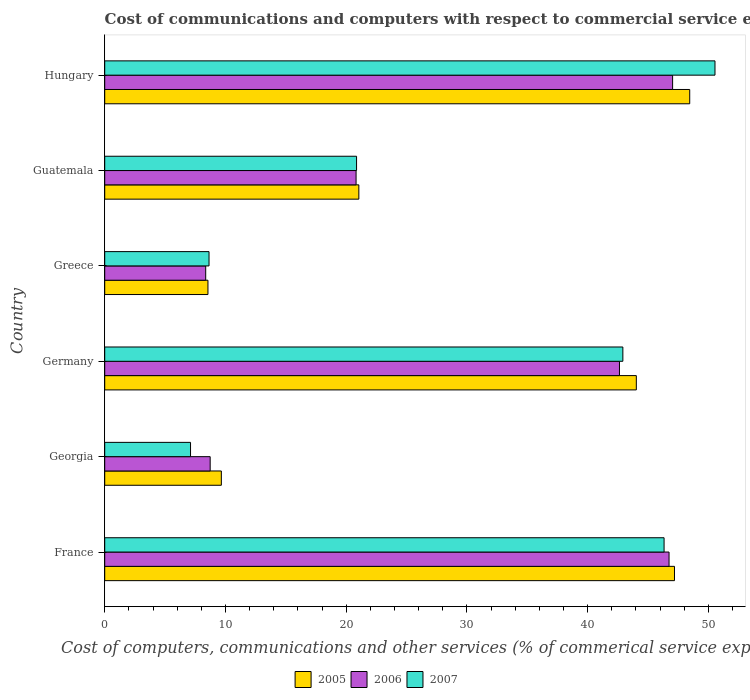How many different coloured bars are there?
Your response must be concise. 3. How many groups of bars are there?
Make the answer very short. 6. What is the label of the 1st group of bars from the top?
Give a very brief answer. Hungary. In how many cases, is the number of bars for a given country not equal to the number of legend labels?
Your response must be concise. 0. What is the cost of communications and computers in 2005 in Georgia?
Offer a very short reply. 9.66. Across all countries, what is the maximum cost of communications and computers in 2006?
Offer a very short reply. 47.04. Across all countries, what is the minimum cost of communications and computers in 2006?
Your answer should be compact. 8.36. In which country was the cost of communications and computers in 2006 maximum?
Offer a very short reply. Hungary. In which country was the cost of communications and computers in 2005 minimum?
Offer a terse response. Greece. What is the total cost of communications and computers in 2006 in the graph?
Make the answer very short. 174.34. What is the difference between the cost of communications and computers in 2007 in Georgia and that in Hungary?
Provide a short and direct response. -43.44. What is the difference between the cost of communications and computers in 2007 in Germany and the cost of communications and computers in 2005 in France?
Make the answer very short. -4.28. What is the average cost of communications and computers in 2007 per country?
Make the answer very short. 29.4. What is the difference between the cost of communications and computers in 2005 and cost of communications and computers in 2006 in Hungary?
Make the answer very short. 1.42. What is the ratio of the cost of communications and computers in 2005 in Germany to that in Hungary?
Your answer should be compact. 0.91. Is the cost of communications and computers in 2005 in Georgia less than that in Guatemala?
Offer a very short reply. Yes. What is the difference between the highest and the second highest cost of communications and computers in 2005?
Offer a terse response. 1.26. What is the difference between the highest and the lowest cost of communications and computers in 2006?
Ensure brevity in your answer.  38.67. What does the 2nd bar from the top in Guatemala represents?
Make the answer very short. 2006. Are all the bars in the graph horizontal?
Provide a succinct answer. Yes. Does the graph contain any zero values?
Your answer should be very brief. No. Does the graph contain grids?
Make the answer very short. No. How many legend labels are there?
Your response must be concise. 3. What is the title of the graph?
Ensure brevity in your answer.  Cost of communications and computers with respect to commercial service exports. What is the label or title of the X-axis?
Ensure brevity in your answer.  Cost of computers, communications and other services (% of commerical service exports). What is the Cost of computers, communications and other services (% of commerical service exports) of 2005 in France?
Ensure brevity in your answer.  47.19. What is the Cost of computers, communications and other services (% of commerical service exports) of 2006 in France?
Your answer should be compact. 46.74. What is the Cost of computers, communications and other services (% of commerical service exports) of 2007 in France?
Provide a short and direct response. 46.33. What is the Cost of computers, communications and other services (% of commerical service exports) of 2005 in Georgia?
Keep it short and to the point. 9.66. What is the Cost of computers, communications and other services (% of commerical service exports) of 2006 in Georgia?
Provide a short and direct response. 8.74. What is the Cost of computers, communications and other services (% of commerical service exports) of 2007 in Georgia?
Provide a succinct answer. 7.11. What is the Cost of computers, communications and other services (% of commerical service exports) of 2005 in Germany?
Keep it short and to the point. 44.03. What is the Cost of computers, communications and other services (% of commerical service exports) of 2006 in Germany?
Make the answer very short. 42.64. What is the Cost of computers, communications and other services (% of commerical service exports) in 2007 in Germany?
Provide a succinct answer. 42.92. What is the Cost of computers, communications and other services (% of commerical service exports) in 2005 in Greece?
Keep it short and to the point. 8.55. What is the Cost of computers, communications and other services (% of commerical service exports) in 2006 in Greece?
Provide a succinct answer. 8.36. What is the Cost of computers, communications and other services (% of commerical service exports) in 2007 in Greece?
Provide a short and direct response. 8.64. What is the Cost of computers, communications and other services (% of commerical service exports) of 2005 in Guatemala?
Your answer should be compact. 21.05. What is the Cost of computers, communications and other services (% of commerical service exports) in 2006 in Guatemala?
Your answer should be very brief. 20.82. What is the Cost of computers, communications and other services (% of commerical service exports) of 2007 in Guatemala?
Offer a very short reply. 20.86. What is the Cost of computers, communications and other services (% of commerical service exports) of 2005 in Hungary?
Offer a terse response. 48.46. What is the Cost of computers, communications and other services (% of commerical service exports) of 2006 in Hungary?
Provide a succinct answer. 47.04. What is the Cost of computers, communications and other services (% of commerical service exports) in 2007 in Hungary?
Offer a terse response. 50.55. Across all countries, what is the maximum Cost of computers, communications and other services (% of commerical service exports) in 2005?
Provide a succinct answer. 48.46. Across all countries, what is the maximum Cost of computers, communications and other services (% of commerical service exports) of 2006?
Your answer should be compact. 47.04. Across all countries, what is the maximum Cost of computers, communications and other services (% of commerical service exports) in 2007?
Offer a very short reply. 50.55. Across all countries, what is the minimum Cost of computers, communications and other services (% of commerical service exports) in 2005?
Offer a terse response. 8.55. Across all countries, what is the minimum Cost of computers, communications and other services (% of commerical service exports) in 2006?
Provide a succinct answer. 8.36. Across all countries, what is the minimum Cost of computers, communications and other services (% of commerical service exports) in 2007?
Offer a terse response. 7.11. What is the total Cost of computers, communications and other services (% of commerical service exports) of 2005 in the graph?
Give a very brief answer. 178.94. What is the total Cost of computers, communications and other services (% of commerical service exports) in 2006 in the graph?
Give a very brief answer. 174.34. What is the total Cost of computers, communications and other services (% of commerical service exports) in 2007 in the graph?
Make the answer very short. 176.41. What is the difference between the Cost of computers, communications and other services (% of commerical service exports) in 2005 in France and that in Georgia?
Ensure brevity in your answer.  37.53. What is the difference between the Cost of computers, communications and other services (% of commerical service exports) of 2006 in France and that in Georgia?
Your response must be concise. 38.01. What is the difference between the Cost of computers, communications and other services (% of commerical service exports) of 2007 in France and that in Georgia?
Your response must be concise. 39.22. What is the difference between the Cost of computers, communications and other services (% of commerical service exports) of 2005 in France and that in Germany?
Ensure brevity in your answer.  3.16. What is the difference between the Cost of computers, communications and other services (% of commerical service exports) of 2006 in France and that in Germany?
Offer a terse response. 4.11. What is the difference between the Cost of computers, communications and other services (% of commerical service exports) in 2007 in France and that in Germany?
Make the answer very short. 3.41. What is the difference between the Cost of computers, communications and other services (% of commerical service exports) of 2005 in France and that in Greece?
Offer a terse response. 38.64. What is the difference between the Cost of computers, communications and other services (% of commerical service exports) of 2006 in France and that in Greece?
Your answer should be compact. 38.38. What is the difference between the Cost of computers, communications and other services (% of commerical service exports) of 2007 in France and that in Greece?
Offer a terse response. 37.69. What is the difference between the Cost of computers, communications and other services (% of commerical service exports) of 2005 in France and that in Guatemala?
Ensure brevity in your answer.  26.14. What is the difference between the Cost of computers, communications and other services (% of commerical service exports) in 2006 in France and that in Guatemala?
Your response must be concise. 25.92. What is the difference between the Cost of computers, communications and other services (% of commerical service exports) of 2007 in France and that in Guatemala?
Provide a succinct answer. 25.47. What is the difference between the Cost of computers, communications and other services (% of commerical service exports) in 2005 in France and that in Hungary?
Keep it short and to the point. -1.26. What is the difference between the Cost of computers, communications and other services (% of commerical service exports) of 2006 in France and that in Hungary?
Make the answer very short. -0.3. What is the difference between the Cost of computers, communications and other services (% of commerical service exports) in 2007 in France and that in Hungary?
Provide a succinct answer. -4.22. What is the difference between the Cost of computers, communications and other services (% of commerical service exports) in 2005 in Georgia and that in Germany?
Provide a succinct answer. -34.37. What is the difference between the Cost of computers, communications and other services (% of commerical service exports) of 2006 in Georgia and that in Germany?
Offer a very short reply. -33.9. What is the difference between the Cost of computers, communications and other services (% of commerical service exports) of 2007 in Georgia and that in Germany?
Provide a short and direct response. -35.81. What is the difference between the Cost of computers, communications and other services (% of commerical service exports) of 2005 in Georgia and that in Greece?
Provide a short and direct response. 1.11. What is the difference between the Cost of computers, communications and other services (% of commerical service exports) of 2006 in Georgia and that in Greece?
Your answer should be very brief. 0.37. What is the difference between the Cost of computers, communications and other services (% of commerical service exports) in 2007 in Georgia and that in Greece?
Offer a terse response. -1.53. What is the difference between the Cost of computers, communications and other services (% of commerical service exports) of 2005 in Georgia and that in Guatemala?
Your answer should be very brief. -11.39. What is the difference between the Cost of computers, communications and other services (% of commerical service exports) of 2006 in Georgia and that in Guatemala?
Ensure brevity in your answer.  -12.08. What is the difference between the Cost of computers, communications and other services (% of commerical service exports) of 2007 in Georgia and that in Guatemala?
Make the answer very short. -13.75. What is the difference between the Cost of computers, communications and other services (% of commerical service exports) in 2005 in Georgia and that in Hungary?
Make the answer very short. -38.8. What is the difference between the Cost of computers, communications and other services (% of commerical service exports) in 2006 in Georgia and that in Hungary?
Make the answer very short. -38.3. What is the difference between the Cost of computers, communications and other services (% of commerical service exports) of 2007 in Georgia and that in Hungary?
Offer a terse response. -43.44. What is the difference between the Cost of computers, communications and other services (% of commerical service exports) of 2005 in Germany and that in Greece?
Make the answer very short. 35.48. What is the difference between the Cost of computers, communications and other services (% of commerical service exports) of 2006 in Germany and that in Greece?
Provide a succinct answer. 34.27. What is the difference between the Cost of computers, communications and other services (% of commerical service exports) in 2007 in Germany and that in Greece?
Offer a very short reply. 34.28. What is the difference between the Cost of computers, communications and other services (% of commerical service exports) in 2005 in Germany and that in Guatemala?
Provide a short and direct response. 22.98. What is the difference between the Cost of computers, communications and other services (% of commerical service exports) in 2006 in Germany and that in Guatemala?
Make the answer very short. 21.82. What is the difference between the Cost of computers, communications and other services (% of commerical service exports) in 2007 in Germany and that in Guatemala?
Offer a terse response. 22.06. What is the difference between the Cost of computers, communications and other services (% of commerical service exports) in 2005 in Germany and that in Hungary?
Give a very brief answer. -4.42. What is the difference between the Cost of computers, communications and other services (% of commerical service exports) in 2006 in Germany and that in Hungary?
Make the answer very short. -4.4. What is the difference between the Cost of computers, communications and other services (% of commerical service exports) of 2007 in Germany and that in Hungary?
Keep it short and to the point. -7.63. What is the difference between the Cost of computers, communications and other services (% of commerical service exports) of 2005 in Greece and that in Guatemala?
Offer a terse response. -12.5. What is the difference between the Cost of computers, communications and other services (% of commerical service exports) in 2006 in Greece and that in Guatemala?
Your response must be concise. -12.45. What is the difference between the Cost of computers, communications and other services (% of commerical service exports) of 2007 in Greece and that in Guatemala?
Keep it short and to the point. -12.22. What is the difference between the Cost of computers, communications and other services (% of commerical service exports) of 2005 in Greece and that in Hungary?
Your response must be concise. -39.91. What is the difference between the Cost of computers, communications and other services (% of commerical service exports) in 2006 in Greece and that in Hungary?
Your answer should be compact. -38.67. What is the difference between the Cost of computers, communications and other services (% of commerical service exports) in 2007 in Greece and that in Hungary?
Make the answer very short. -41.91. What is the difference between the Cost of computers, communications and other services (% of commerical service exports) in 2005 in Guatemala and that in Hungary?
Your response must be concise. -27.41. What is the difference between the Cost of computers, communications and other services (% of commerical service exports) in 2006 in Guatemala and that in Hungary?
Your response must be concise. -26.22. What is the difference between the Cost of computers, communications and other services (% of commerical service exports) in 2007 in Guatemala and that in Hungary?
Your response must be concise. -29.69. What is the difference between the Cost of computers, communications and other services (% of commerical service exports) of 2005 in France and the Cost of computers, communications and other services (% of commerical service exports) of 2006 in Georgia?
Offer a very short reply. 38.46. What is the difference between the Cost of computers, communications and other services (% of commerical service exports) of 2005 in France and the Cost of computers, communications and other services (% of commerical service exports) of 2007 in Georgia?
Provide a succinct answer. 40.09. What is the difference between the Cost of computers, communications and other services (% of commerical service exports) of 2006 in France and the Cost of computers, communications and other services (% of commerical service exports) of 2007 in Georgia?
Your response must be concise. 39.64. What is the difference between the Cost of computers, communications and other services (% of commerical service exports) in 2005 in France and the Cost of computers, communications and other services (% of commerical service exports) in 2006 in Germany?
Your response must be concise. 4.56. What is the difference between the Cost of computers, communications and other services (% of commerical service exports) of 2005 in France and the Cost of computers, communications and other services (% of commerical service exports) of 2007 in Germany?
Your answer should be very brief. 4.28. What is the difference between the Cost of computers, communications and other services (% of commerical service exports) in 2006 in France and the Cost of computers, communications and other services (% of commerical service exports) in 2007 in Germany?
Keep it short and to the point. 3.83. What is the difference between the Cost of computers, communications and other services (% of commerical service exports) of 2005 in France and the Cost of computers, communications and other services (% of commerical service exports) of 2006 in Greece?
Your answer should be compact. 38.83. What is the difference between the Cost of computers, communications and other services (% of commerical service exports) of 2005 in France and the Cost of computers, communications and other services (% of commerical service exports) of 2007 in Greece?
Keep it short and to the point. 38.55. What is the difference between the Cost of computers, communications and other services (% of commerical service exports) in 2006 in France and the Cost of computers, communications and other services (% of commerical service exports) in 2007 in Greece?
Your answer should be compact. 38.1. What is the difference between the Cost of computers, communications and other services (% of commerical service exports) in 2005 in France and the Cost of computers, communications and other services (% of commerical service exports) in 2006 in Guatemala?
Offer a terse response. 26.37. What is the difference between the Cost of computers, communications and other services (% of commerical service exports) in 2005 in France and the Cost of computers, communications and other services (% of commerical service exports) in 2007 in Guatemala?
Provide a short and direct response. 26.33. What is the difference between the Cost of computers, communications and other services (% of commerical service exports) in 2006 in France and the Cost of computers, communications and other services (% of commerical service exports) in 2007 in Guatemala?
Give a very brief answer. 25.88. What is the difference between the Cost of computers, communications and other services (% of commerical service exports) of 2005 in France and the Cost of computers, communications and other services (% of commerical service exports) of 2006 in Hungary?
Provide a short and direct response. 0.16. What is the difference between the Cost of computers, communications and other services (% of commerical service exports) of 2005 in France and the Cost of computers, communications and other services (% of commerical service exports) of 2007 in Hungary?
Provide a short and direct response. -3.35. What is the difference between the Cost of computers, communications and other services (% of commerical service exports) of 2006 in France and the Cost of computers, communications and other services (% of commerical service exports) of 2007 in Hungary?
Ensure brevity in your answer.  -3.8. What is the difference between the Cost of computers, communications and other services (% of commerical service exports) in 2005 in Georgia and the Cost of computers, communications and other services (% of commerical service exports) in 2006 in Germany?
Offer a terse response. -32.98. What is the difference between the Cost of computers, communications and other services (% of commerical service exports) in 2005 in Georgia and the Cost of computers, communications and other services (% of commerical service exports) in 2007 in Germany?
Provide a succinct answer. -33.26. What is the difference between the Cost of computers, communications and other services (% of commerical service exports) in 2006 in Georgia and the Cost of computers, communications and other services (% of commerical service exports) in 2007 in Germany?
Give a very brief answer. -34.18. What is the difference between the Cost of computers, communications and other services (% of commerical service exports) of 2005 in Georgia and the Cost of computers, communications and other services (% of commerical service exports) of 2006 in Greece?
Provide a short and direct response. 1.3. What is the difference between the Cost of computers, communications and other services (% of commerical service exports) of 2005 in Georgia and the Cost of computers, communications and other services (% of commerical service exports) of 2007 in Greece?
Provide a succinct answer. 1.02. What is the difference between the Cost of computers, communications and other services (% of commerical service exports) of 2006 in Georgia and the Cost of computers, communications and other services (% of commerical service exports) of 2007 in Greece?
Your response must be concise. 0.1. What is the difference between the Cost of computers, communications and other services (% of commerical service exports) in 2005 in Georgia and the Cost of computers, communications and other services (% of commerical service exports) in 2006 in Guatemala?
Your answer should be compact. -11.16. What is the difference between the Cost of computers, communications and other services (% of commerical service exports) in 2005 in Georgia and the Cost of computers, communications and other services (% of commerical service exports) in 2007 in Guatemala?
Offer a very short reply. -11.2. What is the difference between the Cost of computers, communications and other services (% of commerical service exports) of 2006 in Georgia and the Cost of computers, communications and other services (% of commerical service exports) of 2007 in Guatemala?
Your answer should be very brief. -12.13. What is the difference between the Cost of computers, communications and other services (% of commerical service exports) of 2005 in Georgia and the Cost of computers, communications and other services (% of commerical service exports) of 2006 in Hungary?
Make the answer very short. -37.38. What is the difference between the Cost of computers, communications and other services (% of commerical service exports) of 2005 in Georgia and the Cost of computers, communications and other services (% of commerical service exports) of 2007 in Hungary?
Provide a short and direct response. -40.89. What is the difference between the Cost of computers, communications and other services (% of commerical service exports) in 2006 in Georgia and the Cost of computers, communications and other services (% of commerical service exports) in 2007 in Hungary?
Provide a short and direct response. -41.81. What is the difference between the Cost of computers, communications and other services (% of commerical service exports) in 2005 in Germany and the Cost of computers, communications and other services (% of commerical service exports) in 2006 in Greece?
Ensure brevity in your answer.  35.67. What is the difference between the Cost of computers, communications and other services (% of commerical service exports) in 2005 in Germany and the Cost of computers, communications and other services (% of commerical service exports) in 2007 in Greece?
Provide a succinct answer. 35.39. What is the difference between the Cost of computers, communications and other services (% of commerical service exports) in 2006 in Germany and the Cost of computers, communications and other services (% of commerical service exports) in 2007 in Greece?
Ensure brevity in your answer.  34. What is the difference between the Cost of computers, communications and other services (% of commerical service exports) of 2005 in Germany and the Cost of computers, communications and other services (% of commerical service exports) of 2006 in Guatemala?
Offer a terse response. 23.21. What is the difference between the Cost of computers, communications and other services (% of commerical service exports) in 2005 in Germany and the Cost of computers, communications and other services (% of commerical service exports) in 2007 in Guatemala?
Provide a short and direct response. 23.17. What is the difference between the Cost of computers, communications and other services (% of commerical service exports) in 2006 in Germany and the Cost of computers, communications and other services (% of commerical service exports) in 2007 in Guatemala?
Your answer should be very brief. 21.78. What is the difference between the Cost of computers, communications and other services (% of commerical service exports) in 2005 in Germany and the Cost of computers, communications and other services (% of commerical service exports) in 2006 in Hungary?
Your answer should be compact. -3.01. What is the difference between the Cost of computers, communications and other services (% of commerical service exports) of 2005 in Germany and the Cost of computers, communications and other services (% of commerical service exports) of 2007 in Hungary?
Your response must be concise. -6.52. What is the difference between the Cost of computers, communications and other services (% of commerical service exports) of 2006 in Germany and the Cost of computers, communications and other services (% of commerical service exports) of 2007 in Hungary?
Offer a terse response. -7.91. What is the difference between the Cost of computers, communications and other services (% of commerical service exports) of 2005 in Greece and the Cost of computers, communications and other services (% of commerical service exports) of 2006 in Guatemala?
Give a very brief answer. -12.27. What is the difference between the Cost of computers, communications and other services (% of commerical service exports) of 2005 in Greece and the Cost of computers, communications and other services (% of commerical service exports) of 2007 in Guatemala?
Keep it short and to the point. -12.31. What is the difference between the Cost of computers, communications and other services (% of commerical service exports) in 2006 in Greece and the Cost of computers, communications and other services (% of commerical service exports) in 2007 in Guatemala?
Give a very brief answer. -12.5. What is the difference between the Cost of computers, communications and other services (% of commerical service exports) in 2005 in Greece and the Cost of computers, communications and other services (% of commerical service exports) in 2006 in Hungary?
Offer a terse response. -38.49. What is the difference between the Cost of computers, communications and other services (% of commerical service exports) of 2005 in Greece and the Cost of computers, communications and other services (% of commerical service exports) of 2007 in Hungary?
Offer a terse response. -42. What is the difference between the Cost of computers, communications and other services (% of commerical service exports) in 2006 in Greece and the Cost of computers, communications and other services (% of commerical service exports) in 2007 in Hungary?
Your answer should be very brief. -42.18. What is the difference between the Cost of computers, communications and other services (% of commerical service exports) in 2005 in Guatemala and the Cost of computers, communications and other services (% of commerical service exports) in 2006 in Hungary?
Provide a succinct answer. -25.99. What is the difference between the Cost of computers, communications and other services (% of commerical service exports) in 2005 in Guatemala and the Cost of computers, communications and other services (% of commerical service exports) in 2007 in Hungary?
Provide a short and direct response. -29.5. What is the difference between the Cost of computers, communications and other services (% of commerical service exports) in 2006 in Guatemala and the Cost of computers, communications and other services (% of commerical service exports) in 2007 in Hungary?
Keep it short and to the point. -29.73. What is the average Cost of computers, communications and other services (% of commerical service exports) in 2005 per country?
Make the answer very short. 29.82. What is the average Cost of computers, communications and other services (% of commerical service exports) in 2006 per country?
Offer a terse response. 29.06. What is the average Cost of computers, communications and other services (% of commerical service exports) of 2007 per country?
Make the answer very short. 29.4. What is the difference between the Cost of computers, communications and other services (% of commerical service exports) in 2005 and Cost of computers, communications and other services (% of commerical service exports) in 2006 in France?
Your answer should be very brief. 0.45. What is the difference between the Cost of computers, communications and other services (% of commerical service exports) in 2005 and Cost of computers, communications and other services (% of commerical service exports) in 2007 in France?
Provide a short and direct response. 0.86. What is the difference between the Cost of computers, communications and other services (% of commerical service exports) of 2006 and Cost of computers, communications and other services (% of commerical service exports) of 2007 in France?
Give a very brief answer. 0.41. What is the difference between the Cost of computers, communications and other services (% of commerical service exports) of 2005 and Cost of computers, communications and other services (% of commerical service exports) of 2006 in Georgia?
Keep it short and to the point. 0.93. What is the difference between the Cost of computers, communications and other services (% of commerical service exports) of 2005 and Cost of computers, communications and other services (% of commerical service exports) of 2007 in Georgia?
Your response must be concise. 2.55. What is the difference between the Cost of computers, communications and other services (% of commerical service exports) of 2006 and Cost of computers, communications and other services (% of commerical service exports) of 2007 in Georgia?
Provide a succinct answer. 1.63. What is the difference between the Cost of computers, communications and other services (% of commerical service exports) of 2005 and Cost of computers, communications and other services (% of commerical service exports) of 2006 in Germany?
Give a very brief answer. 1.4. What is the difference between the Cost of computers, communications and other services (% of commerical service exports) in 2005 and Cost of computers, communications and other services (% of commerical service exports) in 2007 in Germany?
Keep it short and to the point. 1.11. What is the difference between the Cost of computers, communications and other services (% of commerical service exports) of 2006 and Cost of computers, communications and other services (% of commerical service exports) of 2007 in Germany?
Give a very brief answer. -0.28. What is the difference between the Cost of computers, communications and other services (% of commerical service exports) of 2005 and Cost of computers, communications and other services (% of commerical service exports) of 2006 in Greece?
Ensure brevity in your answer.  0.19. What is the difference between the Cost of computers, communications and other services (% of commerical service exports) in 2005 and Cost of computers, communications and other services (% of commerical service exports) in 2007 in Greece?
Give a very brief answer. -0.09. What is the difference between the Cost of computers, communications and other services (% of commerical service exports) in 2006 and Cost of computers, communications and other services (% of commerical service exports) in 2007 in Greece?
Make the answer very short. -0.28. What is the difference between the Cost of computers, communications and other services (% of commerical service exports) of 2005 and Cost of computers, communications and other services (% of commerical service exports) of 2006 in Guatemala?
Provide a succinct answer. 0.23. What is the difference between the Cost of computers, communications and other services (% of commerical service exports) of 2005 and Cost of computers, communications and other services (% of commerical service exports) of 2007 in Guatemala?
Offer a terse response. 0.19. What is the difference between the Cost of computers, communications and other services (% of commerical service exports) of 2006 and Cost of computers, communications and other services (% of commerical service exports) of 2007 in Guatemala?
Offer a very short reply. -0.04. What is the difference between the Cost of computers, communications and other services (% of commerical service exports) in 2005 and Cost of computers, communications and other services (% of commerical service exports) in 2006 in Hungary?
Your answer should be very brief. 1.42. What is the difference between the Cost of computers, communications and other services (% of commerical service exports) in 2005 and Cost of computers, communications and other services (% of commerical service exports) in 2007 in Hungary?
Give a very brief answer. -2.09. What is the difference between the Cost of computers, communications and other services (% of commerical service exports) in 2006 and Cost of computers, communications and other services (% of commerical service exports) in 2007 in Hungary?
Offer a very short reply. -3.51. What is the ratio of the Cost of computers, communications and other services (% of commerical service exports) of 2005 in France to that in Georgia?
Keep it short and to the point. 4.89. What is the ratio of the Cost of computers, communications and other services (% of commerical service exports) of 2006 in France to that in Georgia?
Provide a short and direct response. 5.35. What is the ratio of the Cost of computers, communications and other services (% of commerical service exports) in 2007 in France to that in Georgia?
Offer a very short reply. 6.52. What is the ratio of the Cost of computers, communications and other services (% of commerical service exports) of 2005 in France to that in Germany?
Ensure brevity in your answer.  1.07. What is the ratio of the Cost of computers, communications and other services (% of commerical service exports) of 2006 in France to that in Germany?
Provide a short and direct response. 1.1. What is the ratio of the Cost of computers, communications and other services (% of commerical service exports) in 2007 in France to that in Germany?
Provide a succinct answer. 1.08. What is the ratio of the Cost of computers, communications and other services (% of commerical service exports) in 2005 in France to that in Greece?
Provide a succinct answer. 5.52. What is the ratio of the Cost of computers, communications and other services (% of commerical service exports) in 2006 in France to that in Greece?
Give a very brief answer. 5.59. What is the ratio of the Cost of computers, communications and other services (% of commerical service exports) in 2007 in France to that in Greece?
Offer a very short reply. 5.36. What is the ratio of the Cost of computers, communications and other services (% of commerical service exports) of 2005 in France to that in Guatemala?
Make the answer very short. 2.24. What is the ratio of the Cost of computers, communications and other services (% of commerical service exports) in 2006 in France to that in Guatemala?
Your response must be concise. 2.25. What is the ratio of the Cost of computers, communications and other services (% of commerical service exports) in 2007 in France to that in Guatemala?
Your answer should be compact. 2.22. What is the ratio of the Cost of computers, communications and other services (% of commerical service exports) of 2007 in France to that in Hungary?
Your answer should be compact. 0.92. What is the ratio of the Cost of computers, communications and other services (% of commerical service exports) of 2005 in Georgia to that in Germany?
Keep it short and to the point. 0.22. What is the ratio of the Cost of computers, communications and other services (% of commerical service exports) in 2006 in Georgia to that in Germany?
Give a very brief answer. 0.2. What is the ratio of the Cost of computers, communications and other services (% of commerical service exports) of 2007 in Georgia to that in Germany?
Offer a terse response. 0.17. What is the ratio of the Cost of computers, communications and other services (% of commerical service exports) in 2005 in Georgia to that in Greece?
Make the answer very short. 1.13. What is the ratio of the Cost of computers, communications and other services (% of commerical service exports) of 2006 in Georgia to that in Greece?
Your answer should be very brief. 1.04. What is the ratio of the Cost of computers, communications and other services (% of commerical service exports) in 2007 in Georgia to that in Greece?
Give a very brief answer. 0.82. What is the ratio of the Cost of computers, communications and other services (% of commerical service exports) in 2005 in Georgia to that in Guatemala?
Your answer should be compact. 0.46. What is the ratio of the Cost of computers, communications and other services (% of commerical service exports) in 2006 in Georgia to that in Guatemala?
Your response must be concise. 0.42. What is the ratio of the Cost of computers, communications and other services (% of commerical service exports) in 2007 in Georgia to that in Guatemala?
Keep it short and to the point. 0.34. What is the ratio of the Cost of computers, communications and other services (% of commerical service exports) of 2005 in Georgia to that in Hungary?
Offer a very short reply. 0.2. What is the ratio of the Cost of computers, communications and other services (% of commerical service exports) in 2006 in Georgia to that in Hungary?
Your response must be concise. 0.19. What is the ratio of the Cost of computers, communications and other services (% of commerical service exports) in 2007 in Georgia to that in Hungary?
Give a very brief answer. 0.14. What is the ratio of the Cost of computers, communications and other services (% of commerical service exports) in 2005 in Germany to that in Greece?
Provide a succinct answer. 5.15. What is the ratio of the Cost of computers, communications and other services (% of commerical service exports) of 2006 in Germany to that in Greece?
Make the answer very short. 5.1. What is the ratio of the Cost of computers, communications and other services (% of commerical service exports) of 2007 in Germany to that in Greece?
Your response must be concise. 4.97. What is the ratio of the Cost of computers, communications and other services (% of commerical service exports) in 2005 in Germany to that in Guatemala?
Provide a succinct answer. 2.09. What is the ratio of the Cost of computers, communications and other services (% of commerical service exports) in 2006 in Germany to that in Guatemala?
Your response must be concise. 2.05. What is the ratio of the Cost of computers, communications and other services (% of commerical service exports) of 2007 in Germany to that in Guatemala?
Make the answer very short. 2.06. What is the ratio of the Cost of computers, communications and other services (% of commerical service exports) of 2005 in Germany to that in Hungary?
Offer a terse response. 0.91. What is the ratio of the Cost of computers, communications and other services (% of commerical service exports) in 2006 in Germany to that in Hungary?
Offer a very short reply. 0.91. What is the ratio of the Cost of computers, communications and other services (% of commerical service exports) of 2007 in Germany to that in Hungary?
Ensure brevity in your answer.  0.85. What is the ratio of the Cost of computers, communications and other services (% of commerical service exports) in 2005 in Greece to that in Guatemala?
Give a very brief answer. 0.41. What is the ratio of the Cost of computers, communications and other services (% of commerical service exports) in 2006 in Greece to that in Guatemala?
Offer a very short reply. 0.4. What is the ratio of the Cost of computers, communications and other services (% of commerical service exports) of 2007 in Greece to that in Guatemala?
Offer a terse response. 0.41. What is the ratio of the Cost of computers, communications and other services (% of commerical service exports) of 2005 in Greece to that in Hungary?
Make the answer very short. 0.18. What is the ratio of the Cost of computers, communications and other services (% of commerical service exports) of 2006 in Greece to that in Hungary?
Provide a succinct answer. 0.18. What is the ratio of the Cost of computers, communications and other services (% of commerical service exports) in 2007 in Greece to that in Hungary?
Offer a terse response. 0.17. What is the ratio of the Cost of computers, communications and other services (% of commerical service exports) in 2005 in Guatemala to that in Hungary?
Provide a succinct answer. 0.43. What is the ratio of the Cost of computers, communications and other services (% of commerical service exports) of 2006 in Guatemala to that in Hungary?
Your answer should be very brief. 0.44. What is the ratio of the Cost of computers, communications and other services (% of commerical service exports) of 2007 in Guatemala to that in Hungary?
Provide a short and direct response. 0.41. What is the difference between the highest and the second highest Cost of computers, communications and other services (% of commerical service exports) of 2005?
Offer a terse response. 1.26. What is the difference between the highest and the second highest Cost of computers, communications and other services (% of commerical service exports) in 2006?
Your answer should be compact. 0.3. What is the difference between the highest and the second highest Cost of computers, communications and other services (% of commerical service exports) in 2007?
Offer a very short reply. 4.22. What is the difference between the highest and the lowest Cost of computers, communications and other services (% of commerical service exports) in 2005?
Your answer should be compact. 39.91. What is the difference between the highest and the lowest Cost of computers, communications and other services (% of commerical service exports) of 2006?
Your answer should be compact. 38.67. What is the difference between the highest and the lowest Cost of computers, communications and other services (% of commerical service exports) in 2007?
Ensure brevity in your answer.  43.44. 